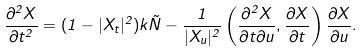<formula> <loc_0><loc_0><loc_500><loc_500>\frac { \partial ^ { 2 } X } { \partial t ^ { 2 } } = ( 1 - | X _ { t } | ^ { 2 } ) k \vec { N } - \frac { 1 } { | X _ { u } | ^ { 2 } } \left ( \frac { \partial ^ { 2 } X } { \partial t \partial u } , \frac { \partial X } { \partial t } \right ) \frac { \partial X } { \partial u } .</formula> 